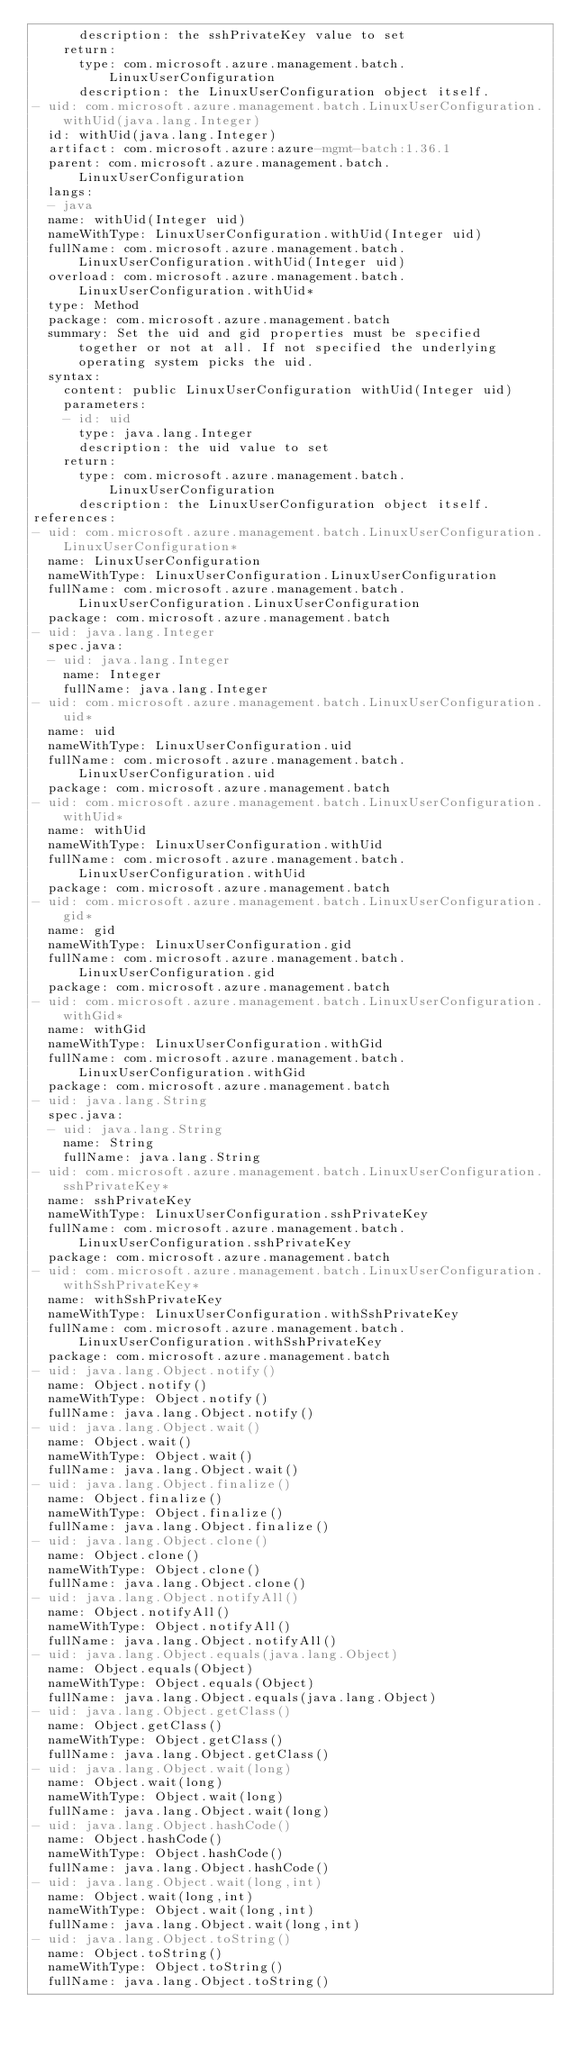Convert code to text. <code><loc_0><loc_0><loc_500><loc_500><_YAML_>      description: the sshPrivateKey value to set
    return:
      type: com.microsoft.azure.management.batch.LinuxUserConfiguration
      description: the LinuxUserConfiguration object itself.
- uid: com.microsoft.azure.management.batch.LinuxUserConfiguration.withUid(java.lang.Integer)
  id: withUid(java.lang.Integer)
  artifact: com.microsoft.azure:azure-mgmt-batch:1.36.1
  parent: com.microsoft.azure.management.batch.LinuxUserConfiguration
  langs:
  - java
  name: withUid(Integer uid)
  nameWithType: LinuxUserConfiguration.withUid(Integer uid)
  fullName: com.microsoft.azure.management.batch.LinuxUserConfiguration.withUid(Integer uid)
  overload: com.microsoft.azure.management.batch.LinuxUserConfiguration.withUid*
  type: Method
  package: com.microsoft.azure.management.batch
  summary: Set the uid and gid properties must be specified together or not at all. If not specified the underlying operating system picks the uid.
  syntax:
    content: public LinuxUserConfiguration withUid(Integer uid)
    parameters:
    - id: uid
      type: java.lang.Integer
      description: the uid value to set
    return:
      type: com.microsoft.azure.management.batch.LinuxUserConfiguration
      description: the LinuxUserConfiguration object itself.
references:
- uid: com.microsoft.azure.management.batch.LinuxUserConfiguration.LinuxUserConfiguration*
  name: LinuxUserConfiguration
  nameWithType: LinuxUserConfiguration.LinuxUserConfiguration
  fullName: com.microsoft.azure.management.batch.LinuxUserConfiguration.LinuxUserConfiguration
  package: com.microsoft.azure.management.batch
- uid: java.lang.Integer
  spec.java:
  - uid: java.lang.Integer
    name: Integer
    fullName: java.lang.Integer
- uid: com.microsoft.azure.management.batch.LinuxUserConfiguration.uid*
  name: uid
  nameWithType: LinuxUserConfiguration.uid
  fullName: com.microsoft.azure.management.batch.LinuxUserConfiguration.uid
  package: com.microsoft.azure.management.batch
- uid: com.microsoft.azure.management.batch.LinuxUserConfiguration.withUid*
  name: withUid
  nameWithType: LinuxUserConfiguration.withUid
  fullName: com.microsoft.azure.management.batch.LinuxUserConfiguration.withUid
  package: com.microsoft.azure.management.batch
- uid: com.microsoft.azure.management.batch.LinuxUserConfiguration.gid*
  name: gid
  nameWithType: LinuxUserConfiguration.gid
  fullName: com.microsoft.azure.management.batch.LinuxUserConfiguration.gid
  package: com.microsoft.azure.management.batch
- uid: com.microsoft.azure.management.batch.LinuxUserConfiguration.withGid*
  name: withGid
  nameWithType: LinuxUserConfiguration.withGid
  fullName: com.microsoft.azure.management.batch.LinuxUserConfiguration.withGid
  package: com.microsoft.azure.management.batch
- uid: java.lang.String
  spec.java:
  - uid: java.lang.String
    name: String
    fullName: java.lang.String
- uid: com.microsoft.azure.management.batch.LinuxUserConfiguration.sshPrivateKey*
  name: sshPrivateKey
  nameWithType: LinuxUserConfiguration.sshPrivateKey
  fullName: com.microsoft.azure.management.batch.LinuxUserConfiguration.sshPrivateKey
  package: com.microsoft.azure.management.batch
- uid: com.microsoft.azure.management.batch.LinuxUserConfiguration.withSshPrivateKey*
  name: withSshPrivateKey
  nameWithType: LinuxUserConfiguration.withSshPrivateKey
  fullName: com.microsoft.azure.management.batch.LinuxUserConfiguration.withSshPrivateKey
  package: com.microsoft.azure.management.batch
- uid: java.lang.Object.notify()
  name: Object.notify()
  nameWithType: Object.notify()
  fullName: java.lang.Object.notify()
- uid: java.lang.Object.wait()
  name: Object.wait()
  nameWithType: Object.wait()
  fullName: java.lang.Object.wait()
- uid: java.lang.Object.finalize()
  name: Object.finalize()
  nameWithType: Object.finalize()
  fullName: java.lang.Object.finalize()
- uid: java.lang.Object.clone()
  name: Object.clone()
  nameWithType: Object.clone()
  fullName: java.lang.Object.clone()
- uid: java.lang.Object.notifyAll()
  name: Object.notifyAll()
  nameWithType: Object.notifyAll()
  fullName: java.lang.Object.notifyAll()
- uid: java.lang.Object.equals(java.lang.Object)
  name: Object.equals(Object)
  nameWithType: Object.equals(Object)
  fullName: java.lang.Object.equals(java.lang.Object)
- uid: java.lang.Object.getClass()
  name: Object.getClass()
  nameWithType: Object.getClass()
  fullName: java.lang.Object.getClass()
- uid: java.lang.Object.wait(long)
  name: Object.wait(long)
  nameWithType: Object.wait(long)
  fullName: java.lang.Object.wait(long)
- uid: java.lang.Object.hashCode()
  name: Object.hashCode()
  nameWithType: Object.hashCode()
  fullName: java.lang.Object.hashCode()
- uid: java.lang.Object.wait(long,int)
  name: Object.wait(long,int)
  nameWithType: Object.wait(long,int)
  fullName: java.lang.Object.wait(long,int)
- uid: java.lang.Object.toString()
  name: Object.toString()
  nameWithType: Object.toString()
  fullName: java.lang.Object.toString()
</code> 